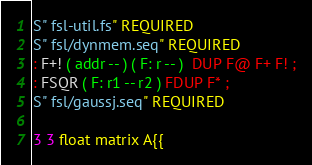Convert code to text. <code><loc_0><loc_0><loc_500><loc_500><_Forth_>S" fsl-util.fs" REQUIRED
S" fsl/dynmem.seq" REQUIRED
: F+! ( addr -- ) ( F: r -- )  DUP F@ F+ F! ;
: FSQR ( F: r1 -- r2 ) FDUP F* ;
S" fsl/gaussj.seq" REQUIRED

3 3 float matrix A{{</code> 